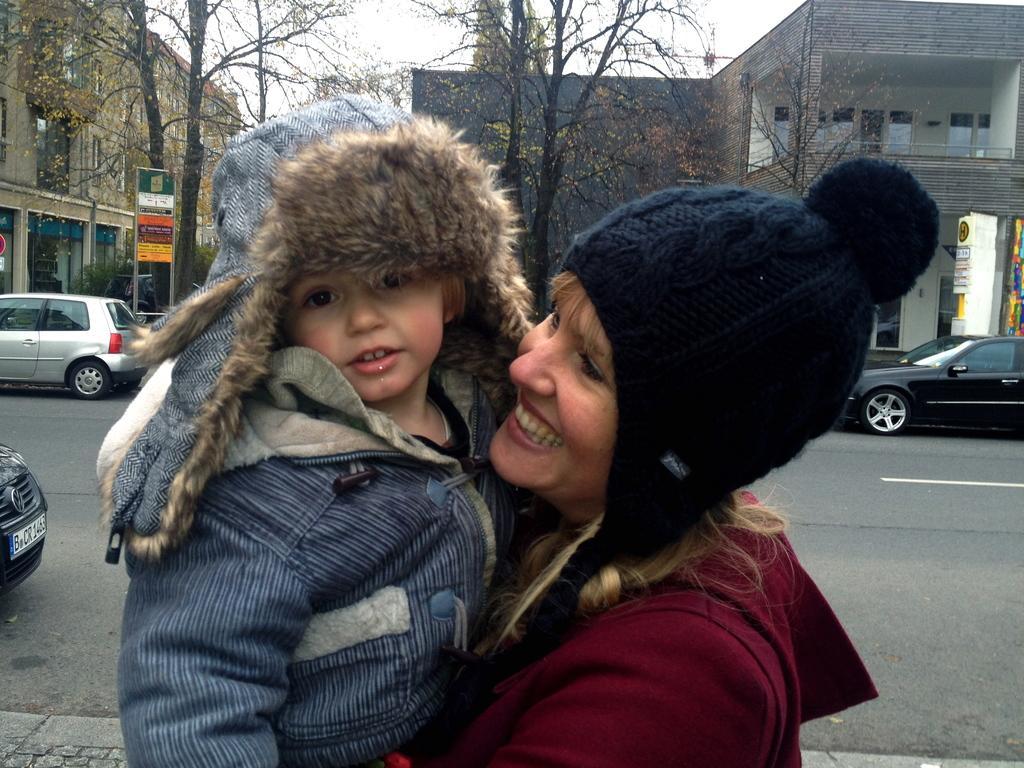Could you give a brief overview of what you see in this image? This is the woman standing and smiling. She is holding a kid in her hands. This kid wore a jerkin. I can see the cars on the road. These are the trees. I think these are the boards attached to the poles. These are the buildings with glass doors and windows. 